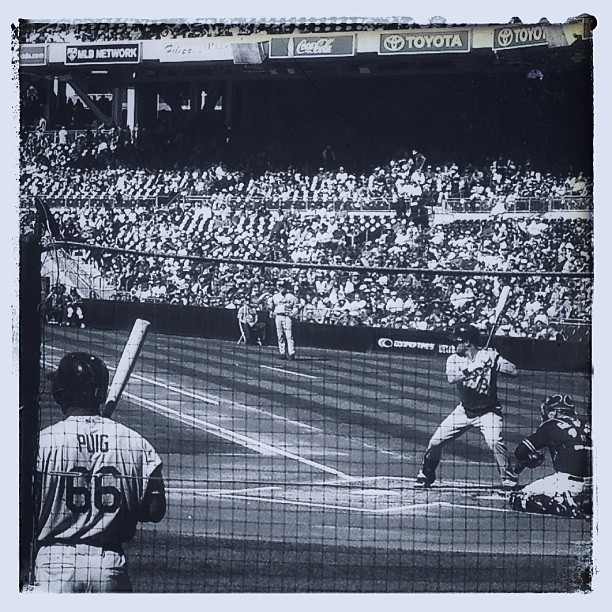Identify and read out the text in this image. CocaCola TOYOTA TOYATO B PUIG 66 